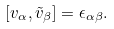Convert formula to latex. <formula><loc_0><loc_0><loc_500><loc_500>[ v _ { \alpha } , \tilde { v } _ { \beta } ] = \epsilon _ { \alpha \beta } .</formula> 